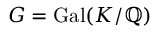<formula> <loc_0><loc_0><loc_500><loc_500>G = { G a l } ( K / \mathbb { Q } )</formula> 